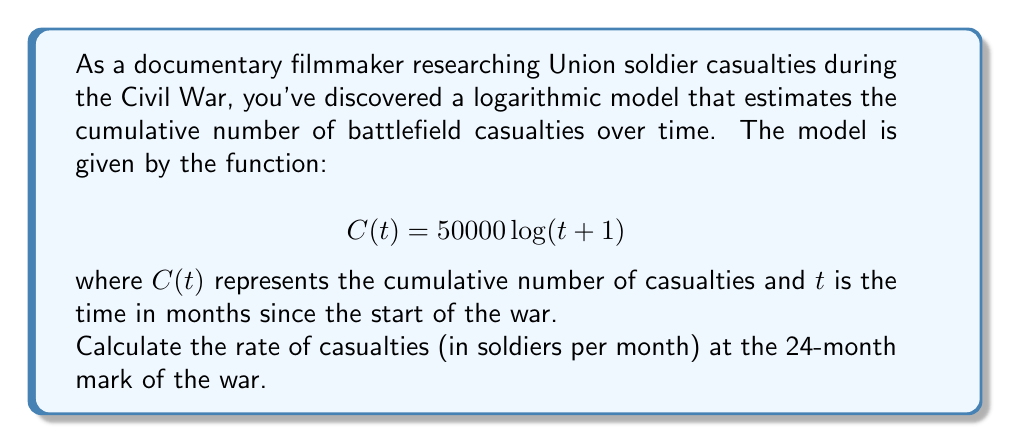What is the answer to this math problem? To find the rate of casualties at a specific point in time, we need to calculate the derivative of the given function $C(t)$ and evaluate it at $t=24$.

Step 1: Calculate the derivative of $C(t)$
$$C(t) = 50000 \log(t+1)$$
$$C'(t) = 50000 \cdot \frac{1}{t+1}$$

Step 2: Evaluate $C'(t)$ at $t=24$
$$C'(24) = 50000 \cdot \frac{1}{24+1} = \frac{50000}{25}$$

Step 3: Simplify the fraction
$$\frac{50000}{25} = 2000$$

Therefore, the rate of casualties at the 24-month mark is 2000 soldiers per month.
Answer: 2000 soldiers/month 